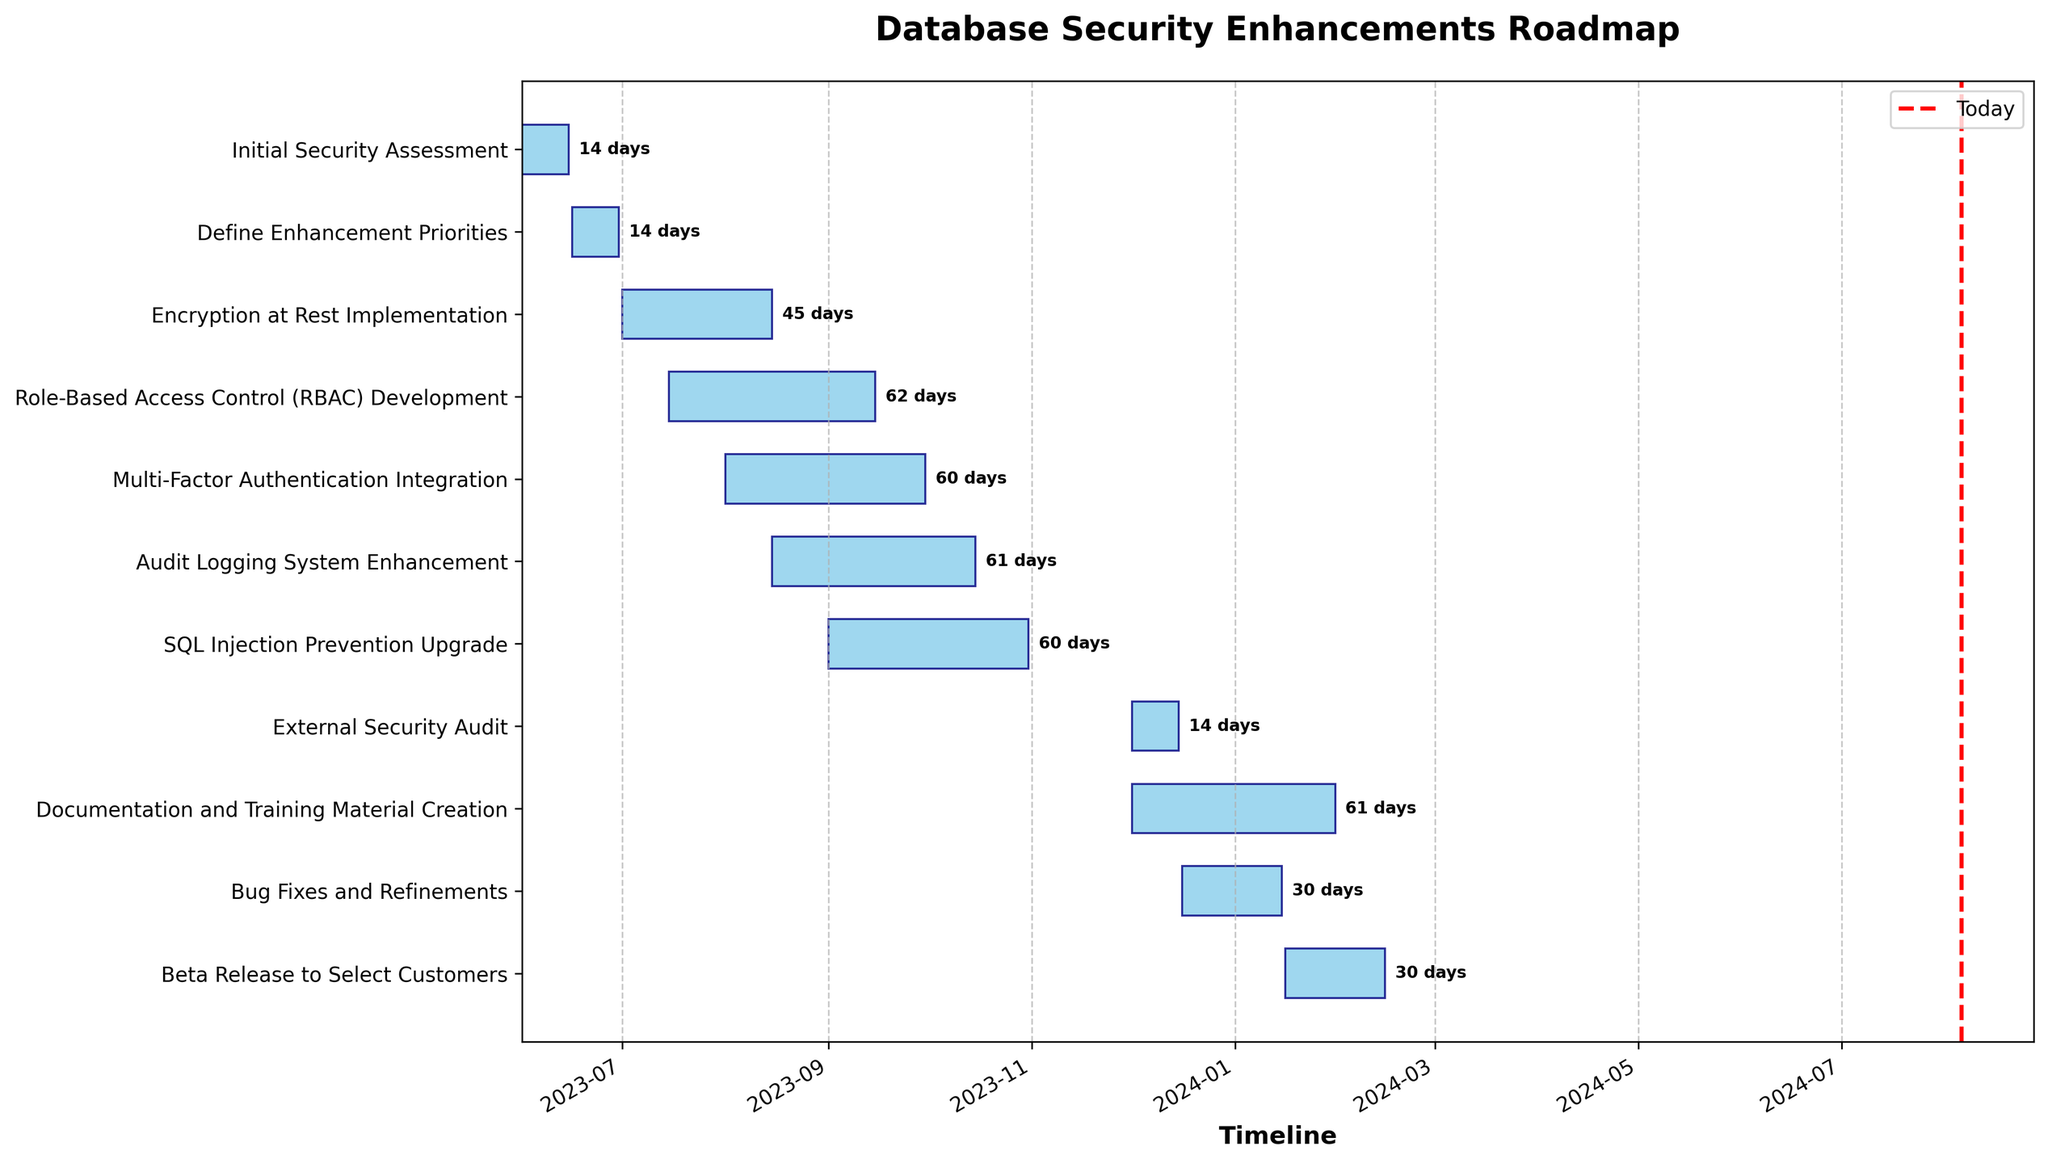What's the title of the Gantt chart? The title is written at the top of the chart and describes the purpose of the Gantt chart.
Answer: Database Security Enhancements Roadmap Which task starts first? The initial task is located at the top of the chart, and it is the first bar starting from the left-hand side.
Answer: Initial Security Assessment How long does the Encryption at Rest Implementation take? The duration is annotated next to the bar representing the task.
Answer: 45 days What is the end date of the Audit Logging System Enhancement task? The end date can be found at the right end of the respective bar, along with the annotated duration.
Answer: 2023-10-15 Which task ends last? The last task is the one that extends furthest to the right.
Answer: Documentation and Training Material Creation Which task has the shortest duration? By looking at the durations annotated next to each bar, the shortest duration can be identified.
Answer: Initial Security Assessment How many tasks start after August 1, 2023? Count the number of tasks that have their start dates after August 1, 2023, as shown on the x-axis and aligning with the bars.
Answer: 3 Which two tasks are running in parallel during September 2023? Identify tasks that have overlapping bars within the time frame of September 2023.
Answer: RBAC Development and Multi-Factor Authentication Integration What is the total duration from the beginning of the first task to the end of the last task? By calculating the total time span from the start date of the initial task to the end date of the final task based on the x-axis timeline.
Answer: 2023-06-01 to 2024-01-31 Which milestone marks the transition to external involvement? Look for annotations that delineate tasks leading to external phases or audits.
Answer: External Security Audit 